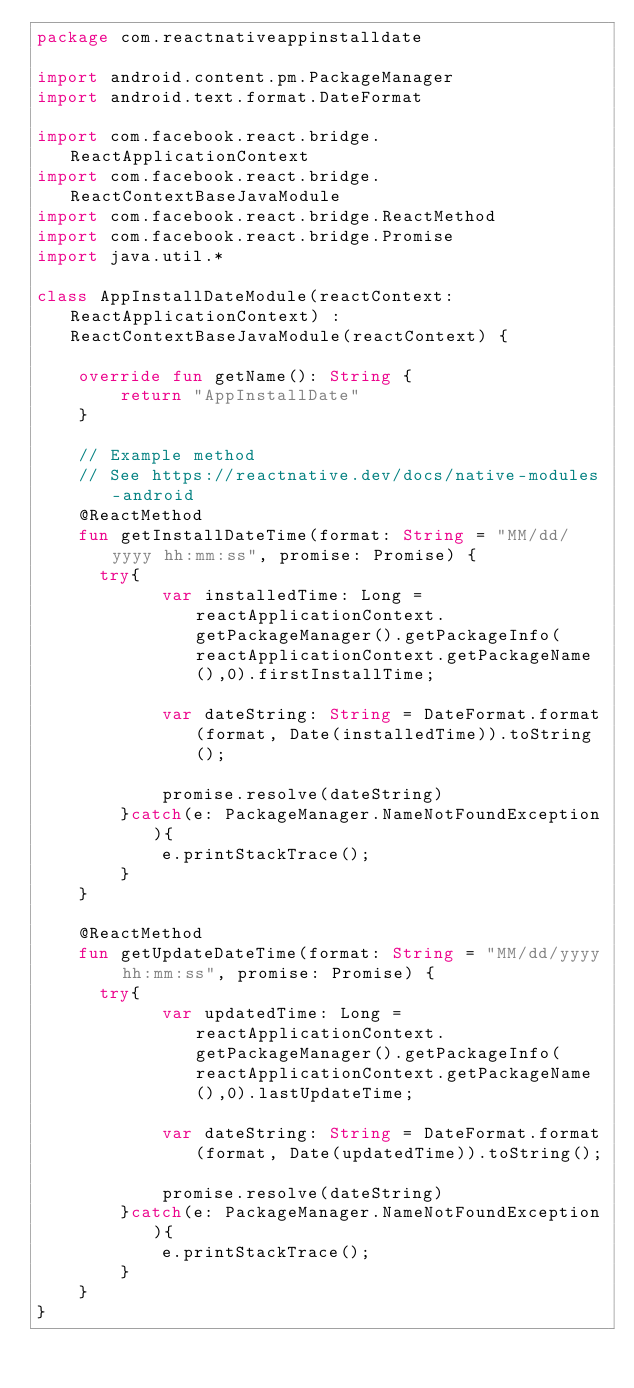Convert code to text. <code><loc_0><loc_0><loc_500><loc_500><_Kotlin_>package com.reactnativeappinstalldate

import android.content.pm.PackageManager
import android.text.format.DateFormat

import com.facebook.react.bridge.ReactApplicationContext
import com.facebook.react.bridge.ReactContextBaseJavaModule
import com.facebook.react.bridge.ReactMethod
import com.facebook.react.bridge.Promise
import java.util.*

class AppInstallDateModule(reactContext: ReactApplicationContext) : ReactContextBaseJavaModule(reactContext) {

    override fun getName(): String {
        return "AppInstallDate"
    }

    // Example method
    // See https://reactnative.dev/docs/native-modules-android
    @ReactMethod
    fun getInstallDateTime(format: String = "MM/dd/yyyy hh:mm:ss", promise: Promise) {
      try{
            var installedTime: Long = reactApplicationContext.getPackageManager().getPackageInfo(reactApplicationContext.getPackageName(),0).firstInstallTime;

            var dateString: String = DateFormat.format(format, Date(installedTime)).toString();

            promise.resolve(dateString)
        }catch(e: PackageManager.NameNotFoundException){
            e.printStackTrace();
        }
    }

    @ReactMethod
    fun getUpdateDateTime(format: String = "MM/dd/yyyy hh:mm:ss", promise: Promise) {
      try{
            var updatedTime: Long = reactApplicationContext.getPackageManager().getPackageInfo(reactApplicationContext.getPackageName(),0).lastUpdateTime;

            var dateString: String = DateFormat.format(format, Date(updatedTime)).toString();

            promise.resolve(dateString)
        }catch(e: PackageManager.NameNotFoundException){
            e.printStackTrace();
        }
    }
}
</code> 